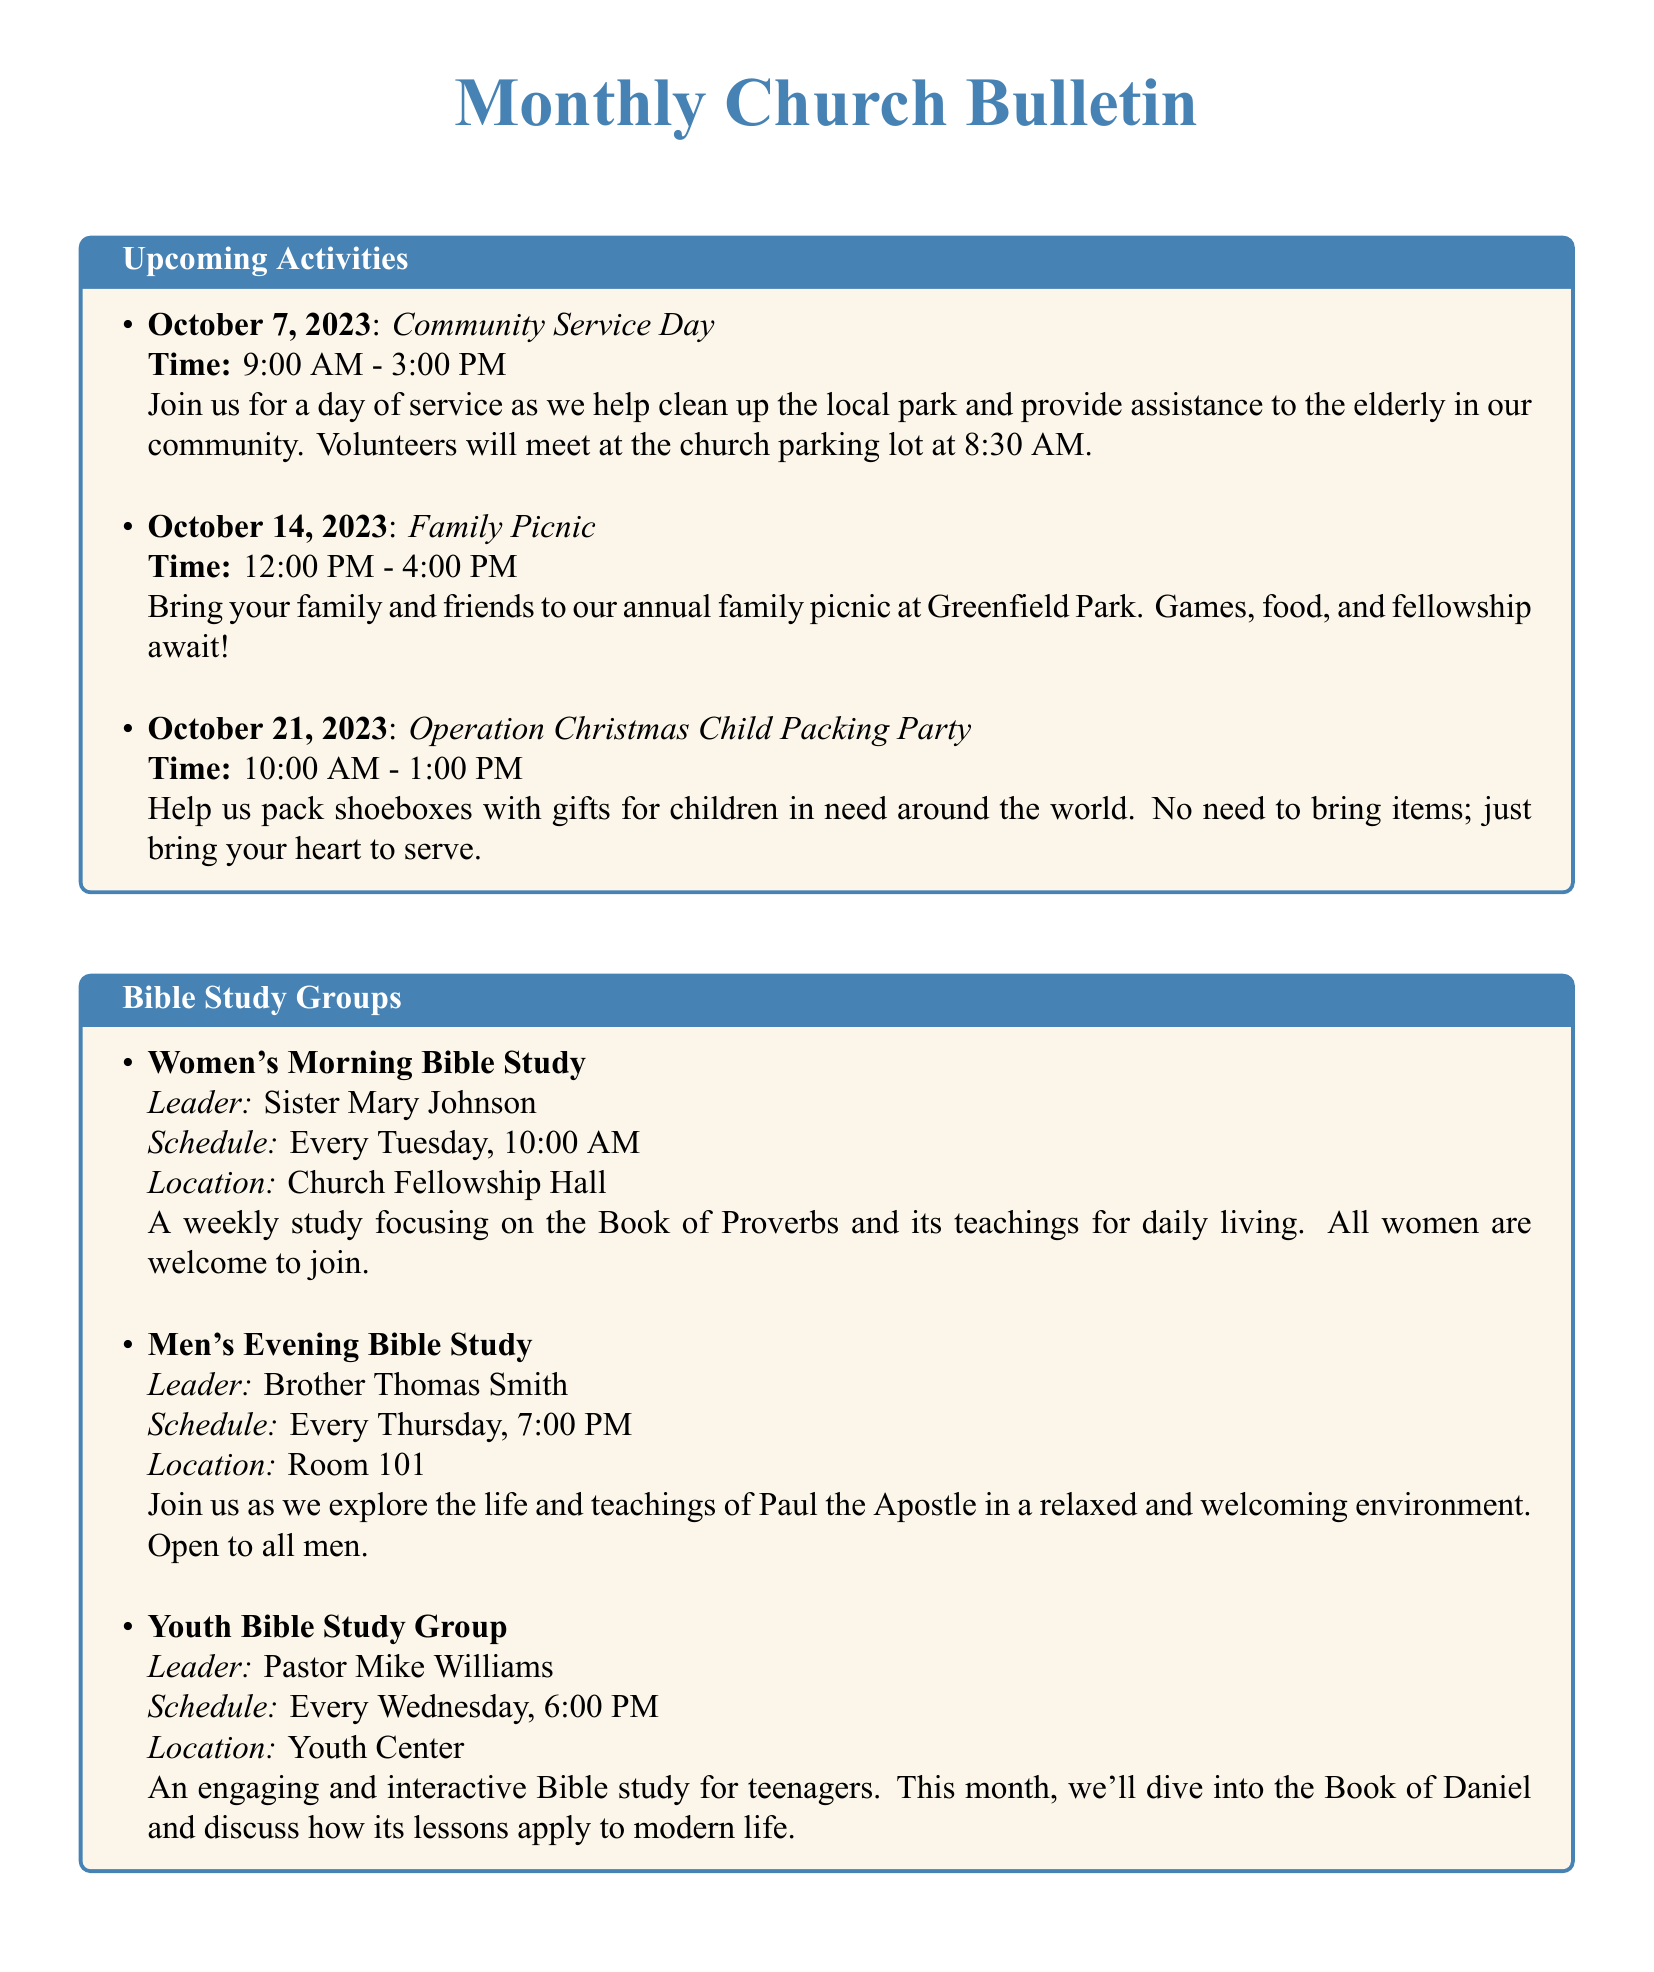What is the date of the Gospel Choir Showcase? The event is listed under Special Gospel Music Services, which shows the date of October 8, 2023.
Answer: October 8, 2023 Who leads the Women's Morning Bible Study? The document states that Sister Mary Johnson is the leader for the Women's Morning Bible Study.
Answer: Sister Mary Johnson What time does the Family Picnic start? The event details indicate that the Family Picnic starts at 12:00 PM.
Answer: 12:00 PM How long is the Operation Christmas Child Packing Party? The listed timing indicates that the Packing Party lasts from 10:00 AM to 1:00 PM, which is a duration of 3 hours.
Answer: 3 hours What is the theme of the service on October 15, 2023? The document describes a special service celebrating the music of Twila Paris for that date.
Answer: Twila Paris Tribute Night How often does the Men's Evening Bible Study occur? The document shows that it occurs every Thursday, indicating a weekly schedule.
Answer: Every Thursday What location hosts the Youth Bible Study Group? The document specifies that the Youth Bible Study Group takes place at the Youth Center.
Answer: Youth Center What time is the Sunday Evening Hymn Sing scheduled? The hymn sing time is clearly noted as 5:00 PM in the document.
Answer: 5:00 PM How many activities are listed under Upcoming Activities? The document includes three events listed under Upcoming Activities.
Answer: Three 